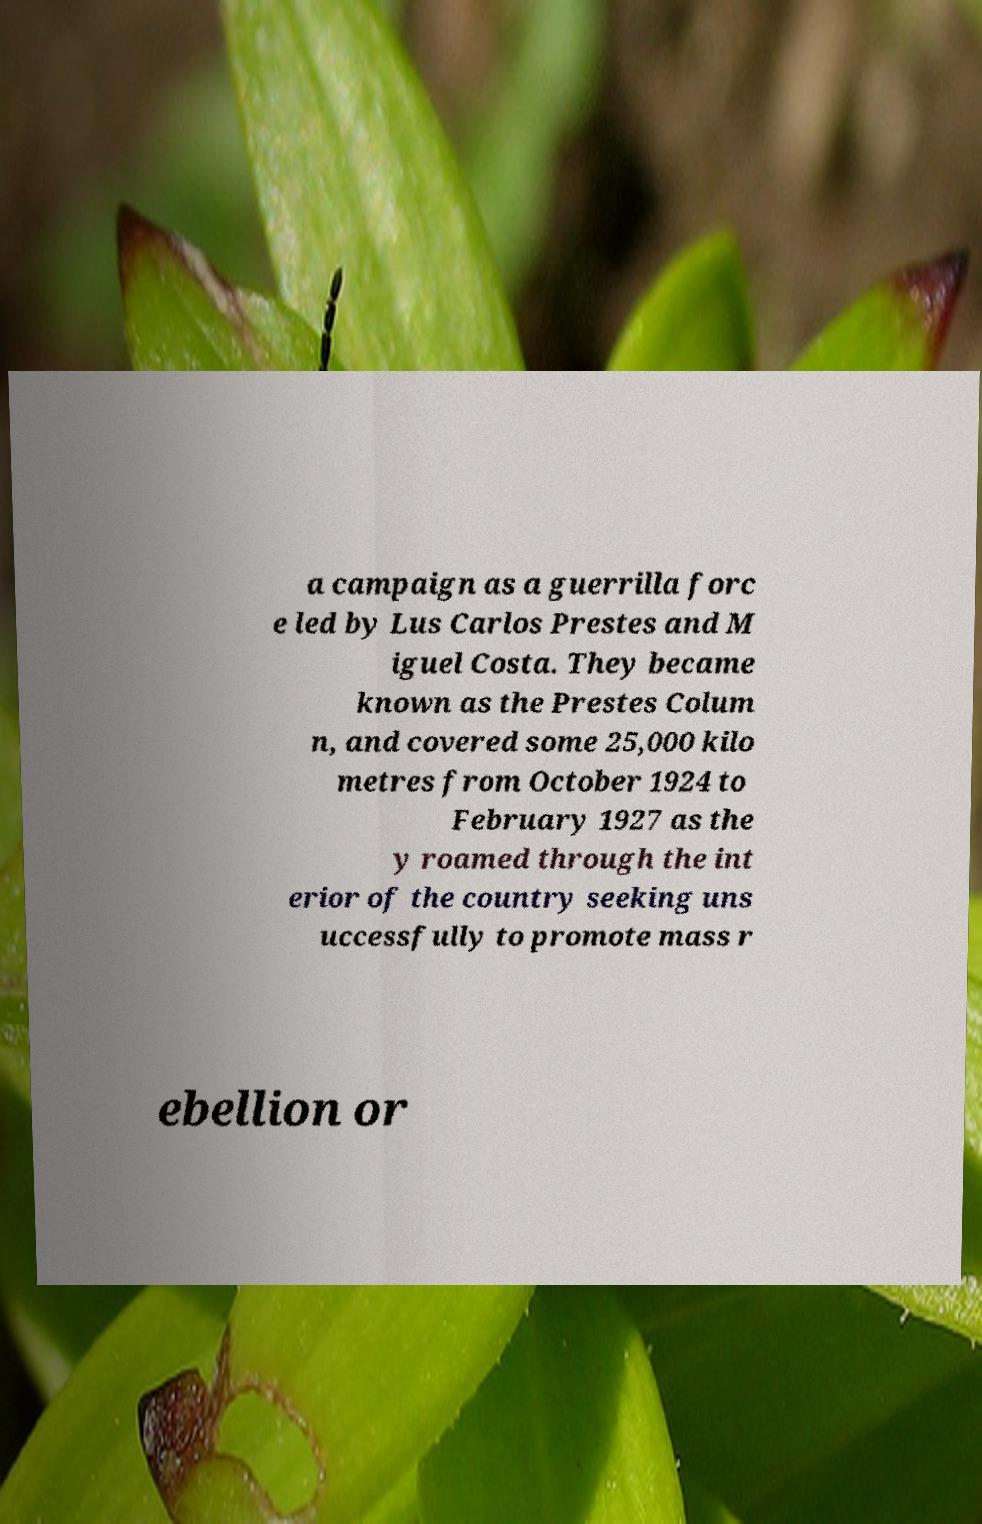Please read and relay the text visible in this image. What does it say? a campaign as a guerrilla forc e led by Lus Carlos Prestes and M iguel Costa. They became known as the Prestes Colum n, and covered some 25,000 kilo metres from October 1924 to February 1927 as the y roamed through the int erior of the country seeking uns uccessfully to promote mass r ebellion or 